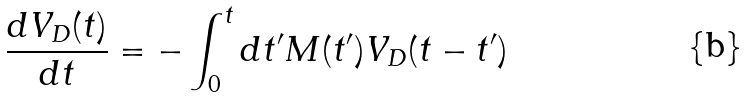<formula> <loc_0><loc_0><loc_500><loc_500>\frac { d V _ { D } ( t ) } { d t } = - \int _ { 0 } ^ { t } d t ^ { \prime } M ( t ^ { \prime } ) V _ { D } ( t - t ^ { \prime } )</formula> 